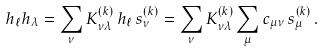<formula> <loc_0><loc_0><loc_500><loc_500>h _ { \ell } h _ { \lambda } = \sum _ { \nu } K ^ { ( k ) } _ { \nu \lambda } \, h _ { \ell } \, s _ { \nu } ^ { ( k ) } = \sum _ { \nu } K ^ { ( k ) } _ { \nu \lambda } \sum _ { \mu } c _ { \mu \nu } \, s _ { \mu } ^ { ( k ) } \, .</formula> 